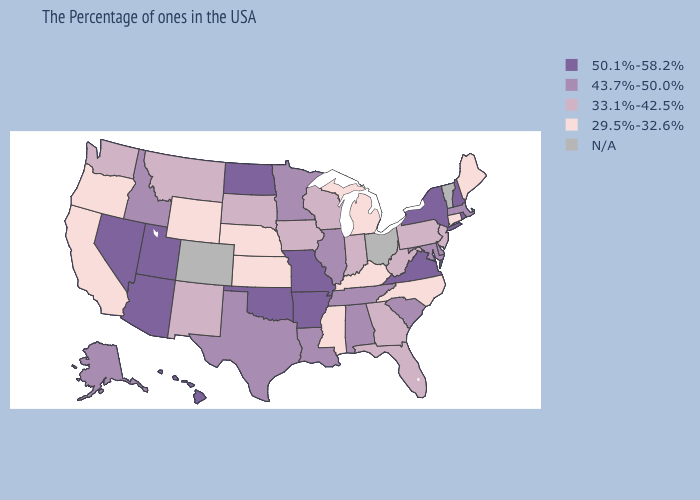Name the states that have a value in the range 33.1%-42.5%?
Be succinct. New Jersey, Pennsylvania, West Virginia, Florida, Georgia, Indiana, Wisconsin, Iowa, South Dakota, New Mexico, Montana, Washington. Name the states that have a value in the range 33.1%-42.5%?
Give a very brief answer. New Jersey, Pennsylvania, West Virginia, Florida, Georgia, Indiana, Wisconsin, Iowa, South Dakota, New Mexico, Montana, Washington. Among the states that border Delaware , which have the lowest value?
Answer briefly. New Jersey, Pennsylvania. What is the highest value in the South ?
Short answer required. 50.1%-58.2%. Does the first symbol in the legend represent the smallest category?
Give a very brief answer. No. Name the states that have a value in the range N/A?
Be succinct. Vermont, Ohio, Colorado. What is the value of Missouri?
Be succinct. 50.1%-58.2%. Name the states that have a value in the range 29.5%-32.6%?
Concise answer only. Maine, Connecticut, North Carolina, Michigan, Kentucky, Mississippi, Kansas, Nebraska, Wyoming, California, Oregon. What is the lowest value in states that border New Hampshire?
Give a very brief answer. 29.5%-32.6%. Name the states that have a value in the range N/A?
Be succinct. Vermont, Ohio, Colorado. Name the states that have a value in the range 50.1%-58.2%?
Concise answer only. Rhode Island, New Hampshire, New York, Virginia, Missouri, Arkansas, Oklahoma, North Dakota, Utah, Arizona, Nevada, Hawaii. Name the states that have a value in the range N/A?
Be succinct. Vermont, Ohio, Colorado. What is the value of Georgia?
Short answer required. 33.1%-42.5%. Is the legend a continuous bar?
Give a very brief answer. No. 